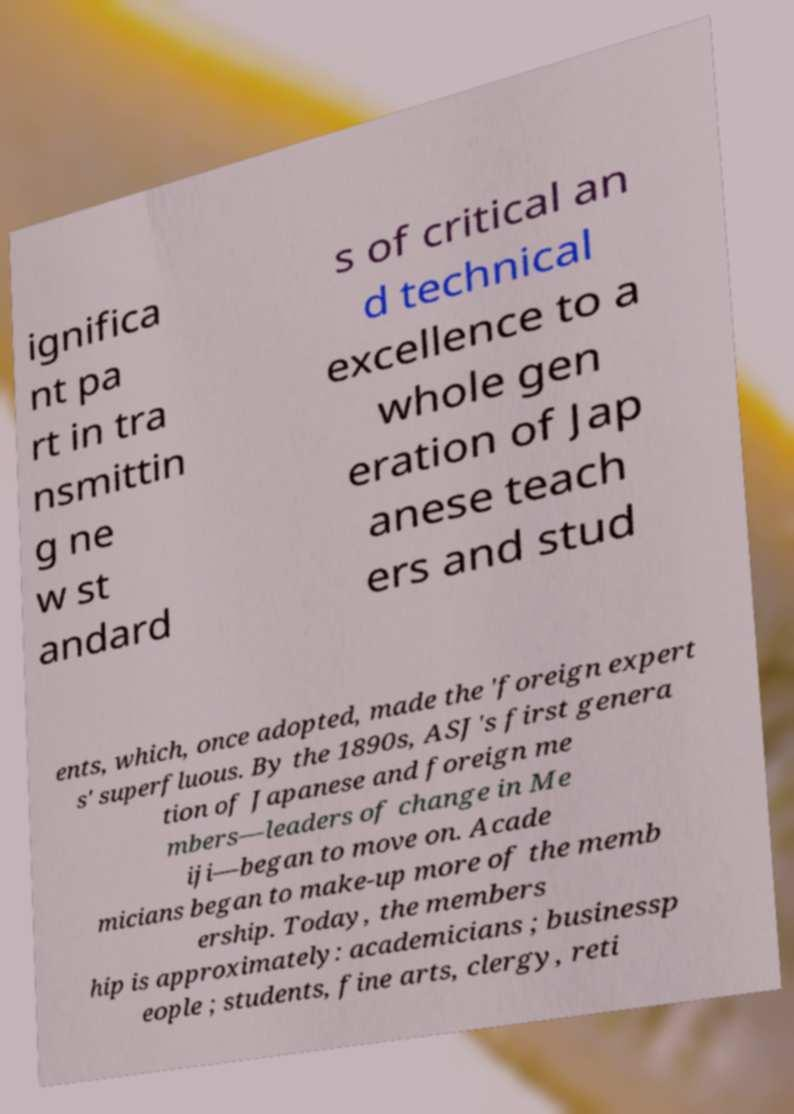What messages or text are displayed in this image? I need them in a readable, typed format. ignifica nt pa rt in tra nsmittin g ne w st andard s of critical an d technical excellence to a whole gen eration of Jap anese teach ers and stud ents, which, once adopted, made the 'foreign expert s' superfluous. By the 1890s, ASJ's first genera tion of Japanese and foreign me mbers—leaders of change in Me iji—began to move on. Acade micians began to make-up more of the memb ership. Today, the members hip is approximately: academicians ; businessp eople ; students, fine arts, clergy, reti 